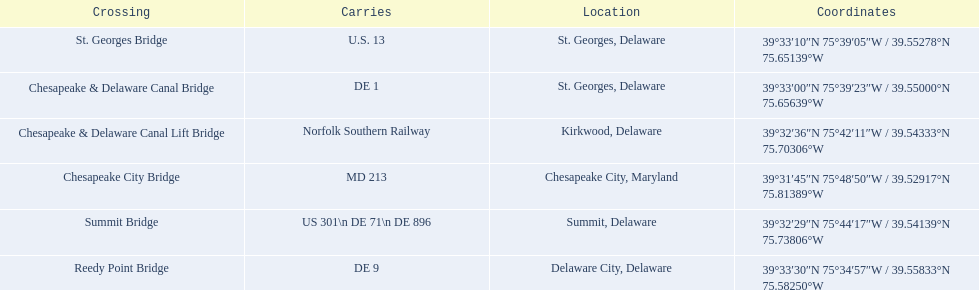Which bridges are in delaware? Summit Bridge, Chesapeake & Delaware Canal Lift Bridge, Chesapeake & Delaware Canal Bridge, St. Georges Bridge, Reedy Point Bridge. Which delaware bridge carries de 9? Reedy Point Bridge. 